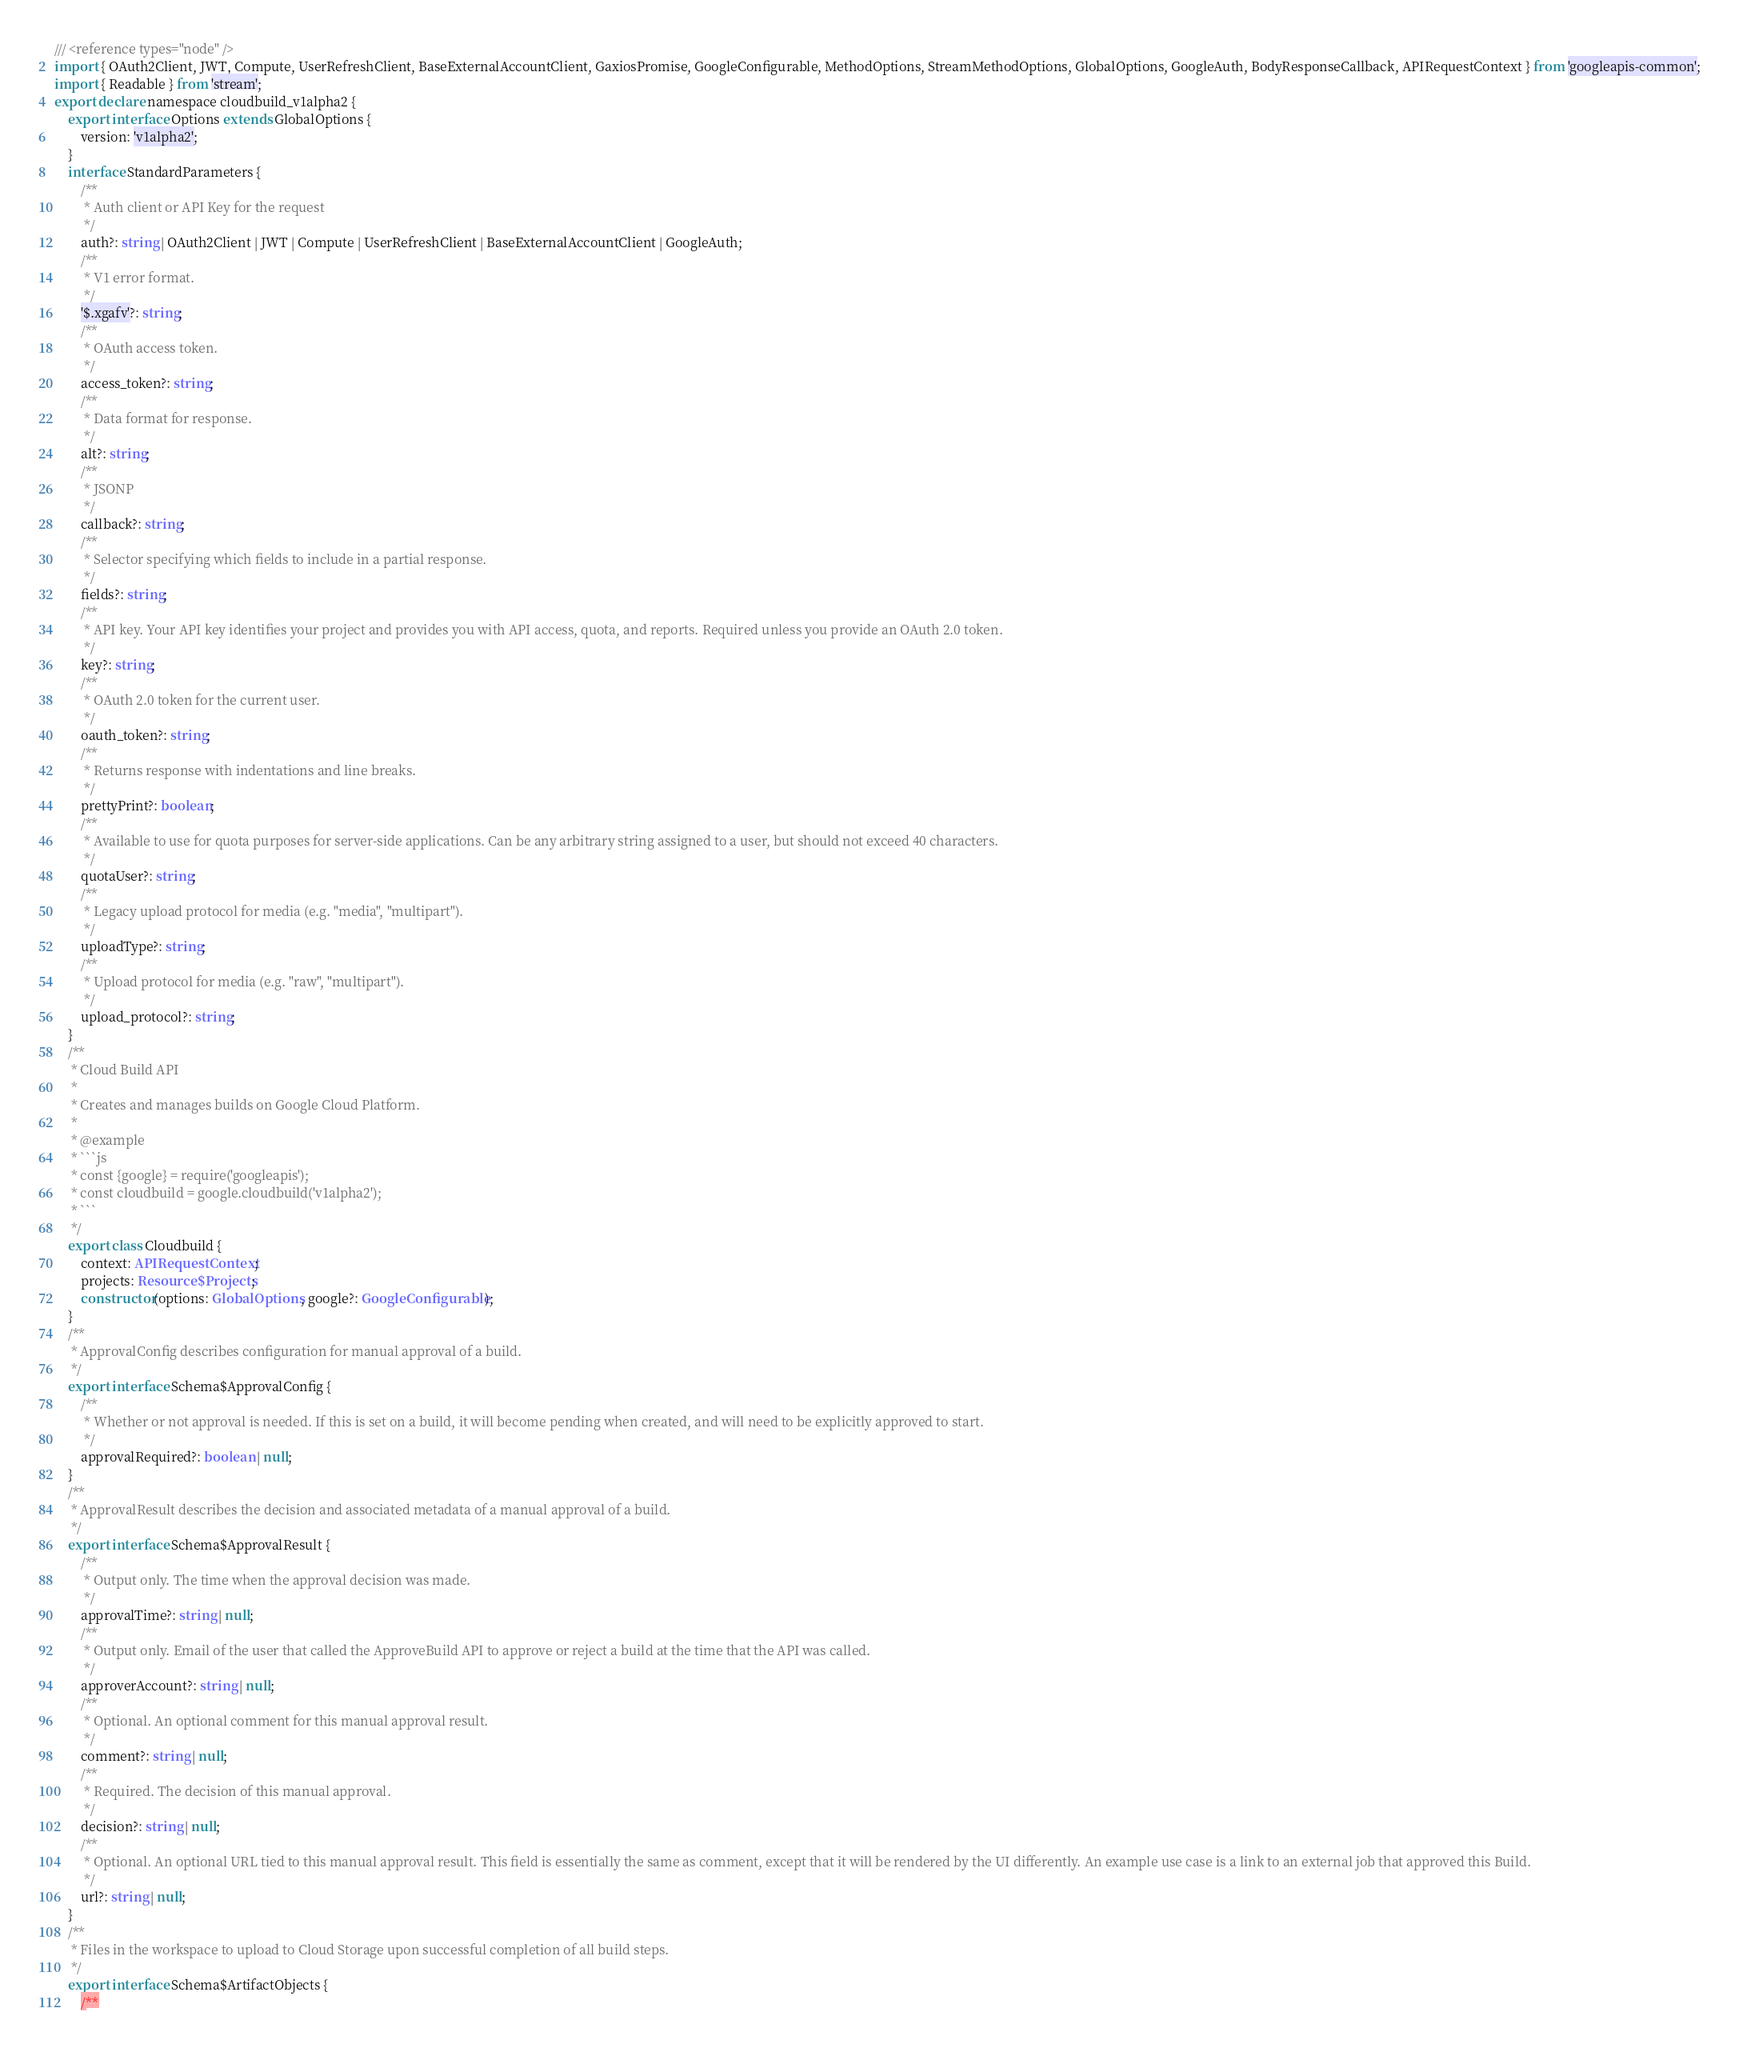Convert code to text. <code><loc_0><loc_0><loc_500><loc_500><_TypeScript_>/// <reference types="node" />
import { OAuth2Client, JWT, Compute, UserRefreshClient, BaseExternalAccountClient, GaxiosPromise, GoogleConfigurable, MethodOptions, StreamMethodOptions, GlobalOptions, GoogleAuth, BodyResponseCallback, APIRequestContext } from 'googleapis-common';
import { Readable } from 'stream';
export declare namespace cloudbuild_v1alpha2 {
    export interface Options extends GlobalOptions {
        version: 'v1alpha2';
    }
    interface StandardParameters {
        /**
         * Auth client or API Key for the request
         */
        auth?: string | OAuth2Client | JWT | Compute | UserRefreshClient | BaseExternalAccountClient | GoogleAuth;
        /**
         * V1 error format.
         */
        '$.xgafv'?: string;
        /**
         * OAuth access token.
         */
        access_token?: string;
        /**
         * Data format for response.
         */
        alt?: string;
        /**
         * JSONP
         */
        callback?: string;
        /**
         * Selector specifying which fields to include in a partial response.
         */
        fields?: string;
        /**
         * API key. Your API key identifies your project and provides you with API access, quota, and reports. Required unless you provide an OAuth 2.0 token.
         */
        key?: string;
        /**
         * OAuth 2.0 token for the current user.
         */
        oauth_token?: string;
        /**
         * Returns response with indentations and line breaks.
         */
        prettyPrint?: boolean;
        /**
         * Available to use for quota purposes for server-side applications. Can be any arbitrary string assigned to a user, but should not exceed 40 characters.
         */
        quotaUser?: string;
        /**
         * Legacy upload protocol for media (e.g. "media", "multipart").
         */
        uploadType?: string;
        /**
         * Upload protocol for media (e.g. "raw", "multipart").
         */
        upload_protocol?: string;
    }
    /**
     * Cloud Build API
     *
     * Creates and manages builds on Google Cloud Platform.
     *
     * @example
     * ```js
     * const {google} = require('googleapis');
     * const cloudbuild = google.cloudbuild('v1alpha2');
     * ```
     */
    export class Cloudbuild {
        context: APIRequestContext;
        projects: Resource$Projects;
        constructor(options: GlobalOptions, google?: GoogleConfigurable);
    }
    /**
     * ApprovalConfig describes configuration for manual approval of a build.
     */
    export interface Schema$ApprovalConfig {
        /**
         * Whether or not approval is needed. If this is set on a build, it will become pending when created, and will need to be explicitly approved to start.
         */
        approvalRequired?: boolean | null;
    }
    /**
     * ApprovalResult describes the decision and associated metadata of a manual approval of a build.
     */
    export interface Schema$ApprovalResult {
        /**
         * Output only. The time when the approval decision was made.
         */
        approvalTime?: string | null;
        /**
         * Output only. Email of the user that called the ApproveBuild API to approve or reject a build at the time that the API was called.
         */
        approverAccount?: string | null;
        /**
         * Optional. An optional comment for this manual approval result.
         */
        comment?: string | null;
        /**
         * Required. The decision of this manual approval.
         */
        decision?: string | null;
        /**
         * Optional. An optional URL tied to this manual approval result. This field is essentially the same as comment, except that it will be rendered by the UI differently. An example use case is a link to an external job that approved this Build.
         */
        url?: string | null;
    }
    /**
     * Files in the workspace to upload to Cloud Storage upon successful completion of all build steps.
     */
    export interface Schema$ArtifactObjects {
        /**</code> 